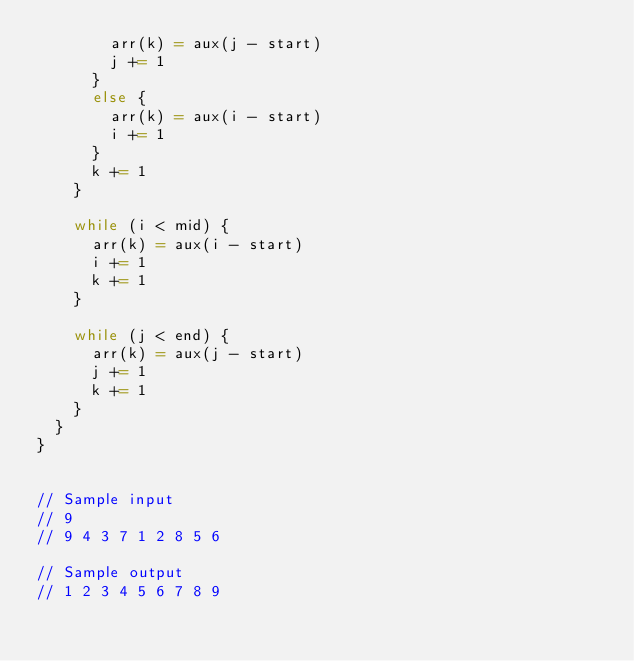Convert code to text. <code><loc_0><loc_0><loc_500><loc_500><_Scala_>        arr(k) = aux(j - start)
        j += 1
      }
      else {
        arr(k) = aux(i - start)
        i += 1
      }
      k += 1
    }

    while (i < mid) {
      arr(k) = aux(i - start)
      i += 1
      k += 1
    }

    while (j < end) {
      arr(k) = aux(j - start)
      j += 1
      k += 1
    }
  }
}


// Sample input
// 9
// 9 4 3 7 1 2 8 5 6

// Sample output
// 1 2 3 4 5 6 7 8 9 </code> 